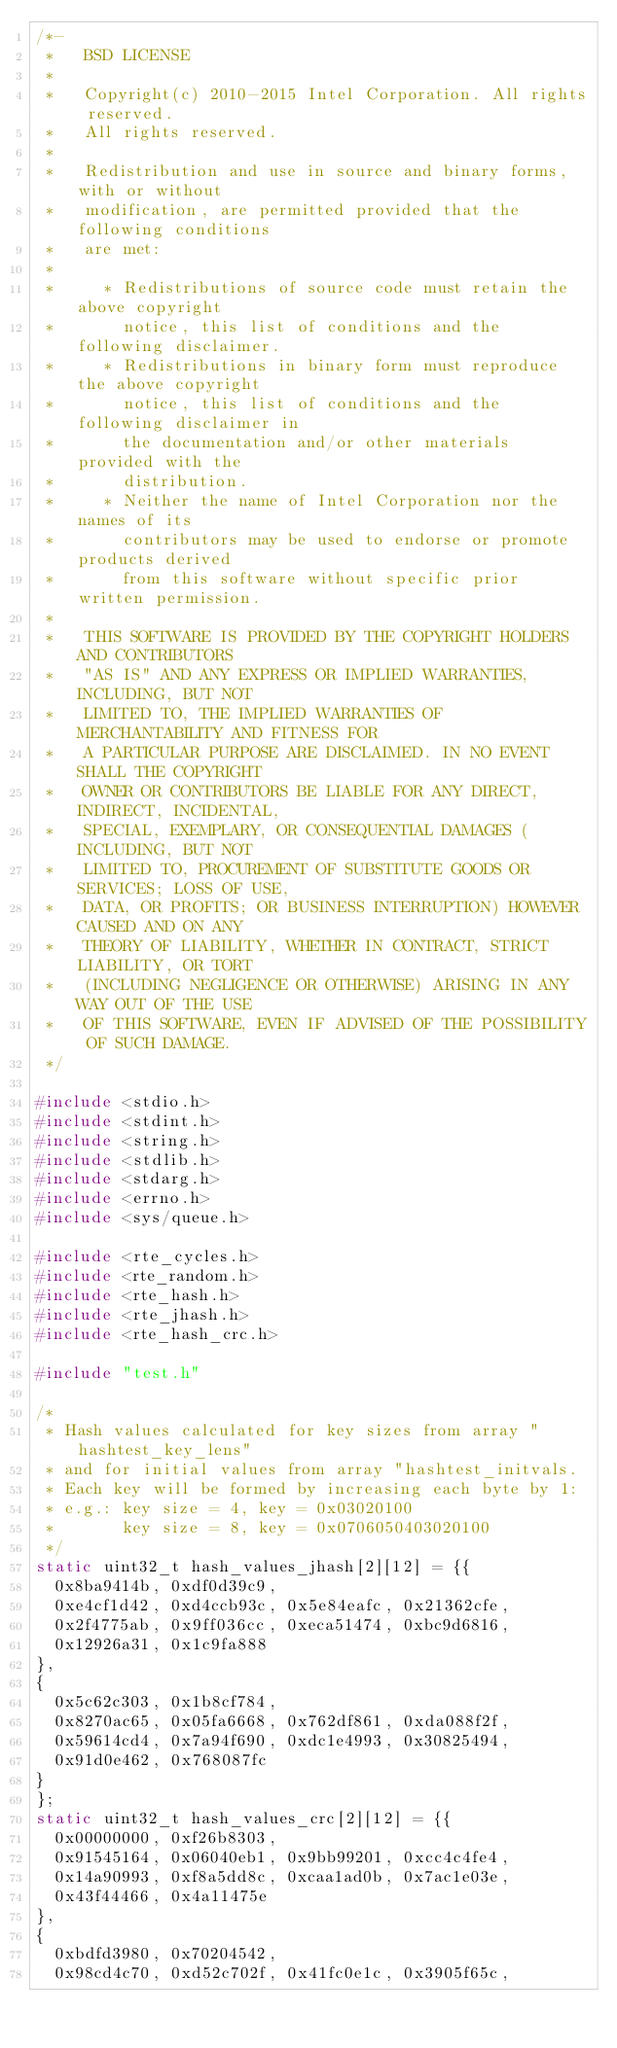<code> <loc_0><loc_0><loc_500><loc_500><_C_>/*-
 *   BSD LICENSE
 *
 *   Copyright(c) 2010-2015 Intel Corporation. All rights reserved.
 *   All rights reserved.
 *
 *   Redistribution and use in source and binary forms, with or without
 *   modification, are permitted provided that the following conditions
 *   are met:
 *
 *     * Redistributions of source code must retain the above copyright
 *       notice, this list of conditions and the following disclaimer.
 *     * Redistributions in binary form must reproduce the above copyright
 *       notice, this list of conditions and the following disclaimer in
 *       the documentation and/or other materials provided with the
 *       distribution.
 *     * Neither the name of Intel Corporation nor the names of its
 *       contributors may be used to endorse or promote products derived
 *       from this software without specific prior written permission.
 *
 *   THIS SOFTWARE IS PROVIDED BY THE COPYRIGHT HOLDERS AND CONTRIBUTORS
 *   "AS IS" AND ANY EXPRESS OR IMPLIED WARRANTIES, INCLUDING, BUT NOT
 *   LIMITED TO, THE IMPLIED WARRANTIES OF MERCHANTABILITY AND FITNESS FOR
 *   A PARTICULAR PURPOSE ARE DISCLAIMED. IN NO EVENT SHALL THE COPYRIGHT
 *   OWNER OR CONTRIBUTORS BE LIABLE FOR ANY DIRECT, INDIRECT, INCIDENTAL,
 *   SPECIAL, EXEMPLARY, OR CONSEQUENTIAL DAMAGES (INCLUDING, BUT NOT
 *   LIMITED TO, PROCUREMENT OF SUBSTITUTE GOODS OR SERVICES; LOSS OF USE,
 *   DATA, OR PROFITS; OR BUSINESS INTERRUPTION) HOWEVER CAUSED AND ON ANY
 *   THEORY OF LIABILITY, WHETHER IN CONTRACT, STRICT LIABILITY, OR TORT
 *   (INCLUDING NEGLIGENCE OR OTHERWISE) ARISING IN ANY WAY OUT OF THE USE
 *   OF THIS SOFTWARE, EVEN IF ADVISED OF THE POSSIBILITY OF SUCH DAMAGE.
 */

#include <stdio.h>
#include <stdint.h>
#include <string.h>
#include <stdlib.h>
#include <stdarg.h>
#include <errno.h>
#include <sys/queue.h>

#include <rte_cycles.h>
#include <rte_random.h>
#include <rte_hash.h>
#include <rte_jhash.h>
#include <rte_hash_crc.h>

#include "test.h"

/*
 * Hash values calculated for key sizes from array "hashtest_key_lens"
 * and for initial values from array "hashtest_initvals.
 * Each key will be formed by increasing each byte by 1:
 * e.g.: key size = 4, key = 0x03020100
 *       key size = 8, key = 0x0706050403020100
 */
static uint32_t hash_values_jhash[2][12] = {{
	0x8ba9414b, 0xdf0d39c9,
	0xe4cf1d42, 0xd4ccb93c, 0x5e84eafc, 0x21362cfe,
	0x2f4775ab, 0x9ff036cc, 0xeca51474, 0xbc9d6816,
	0x12926a31, 0x1c9fa888
},
{
	0x5c62c303, 0x1b8cf784,
	0x8270ac65, 0x05fa6668, 0x762df861, 0xda088f2f,
	0x59614cd4, 0x7a94f690, 0xdc1e4993, 0x30825494,
	0x91d0e462, 0x768087fc
}
};
static uint32_t hash_values_crc[2][12] = {{
	0x00000000, 0xf26b8303,
	0x91545164, 0x06040eb1, 0x9bb99201, 0xcc4c4fe4,
	0x14a90993, 0xf8a5dd8c, 0xcaa1ad0b, 0x7ac1e03e,
	0x43f44466, 0x4a11475e
},
{
	0xbdfd3980, 0x70204542,
	0x98cd4c70, 0xd52c702f, 0x41fc0e1c, 0x3905f65c,</code> 